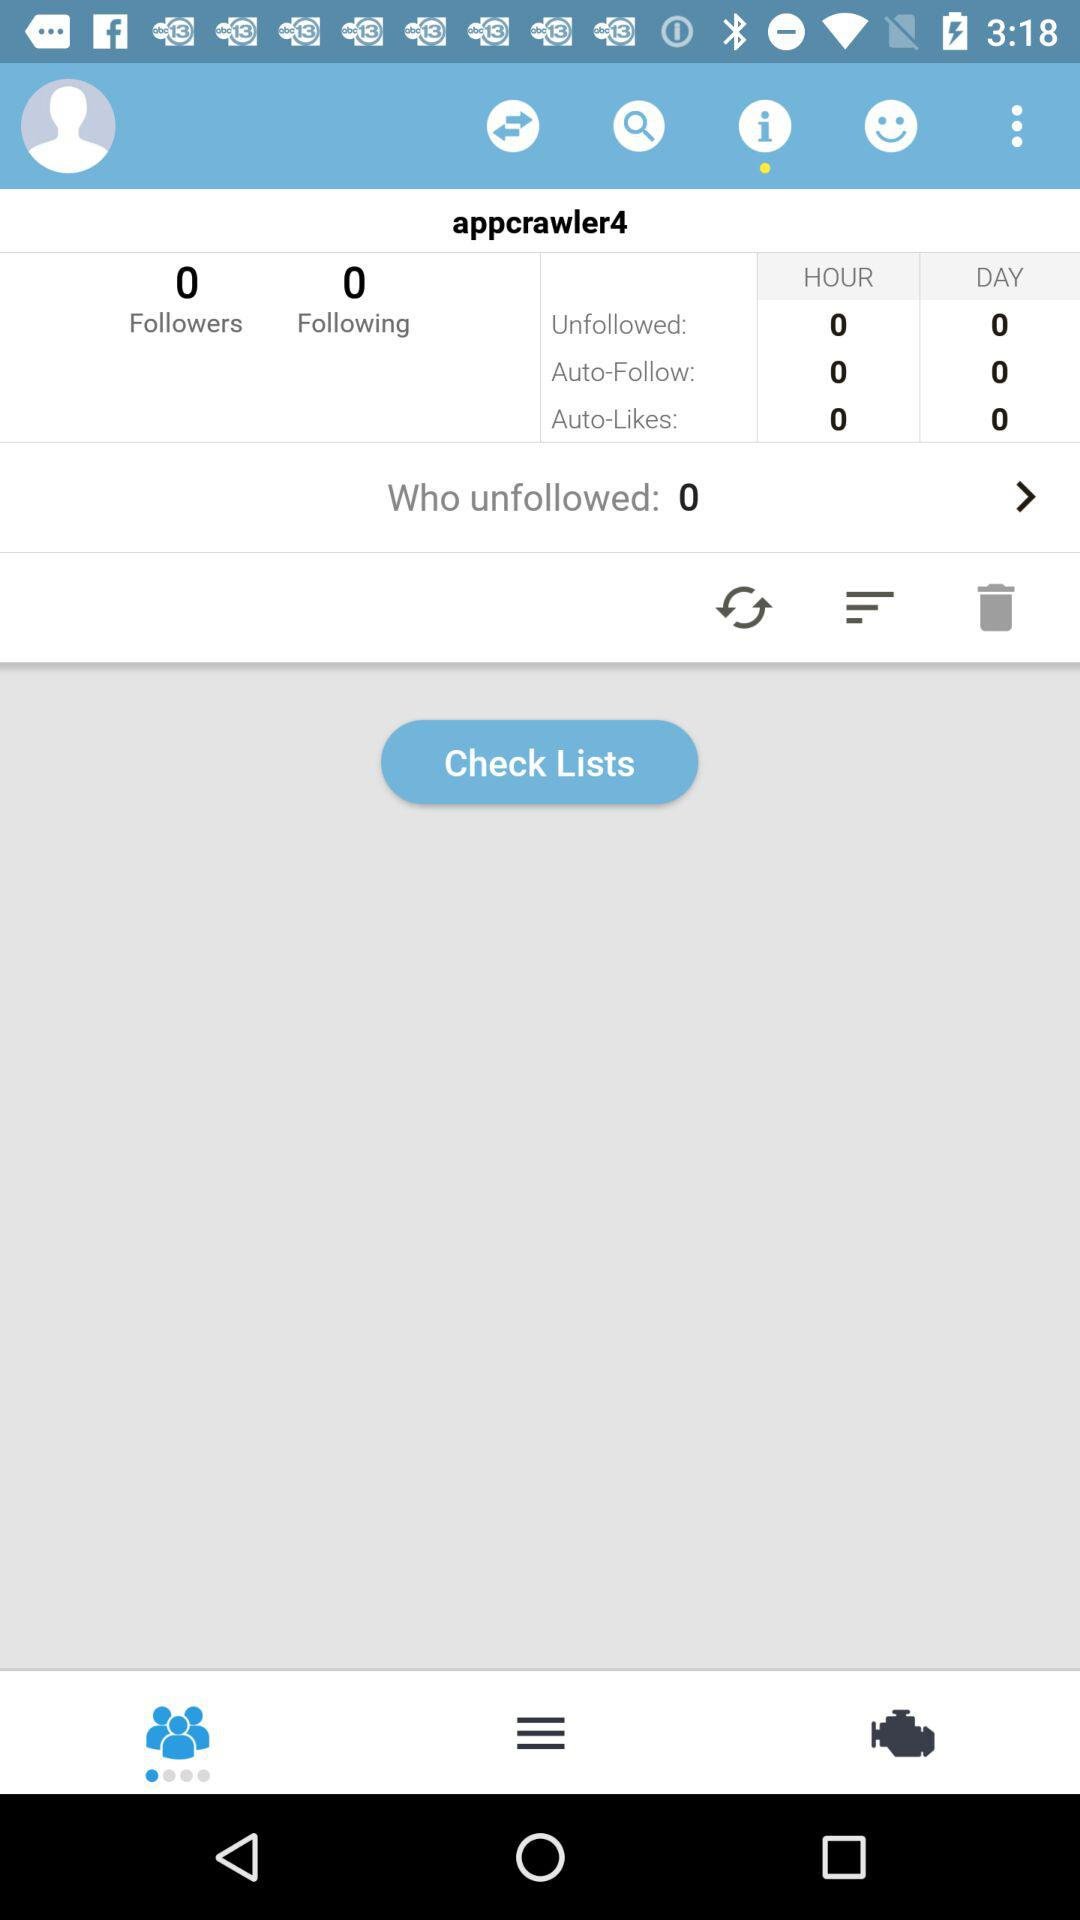How many followers does the person have? The person has 0 followers. 